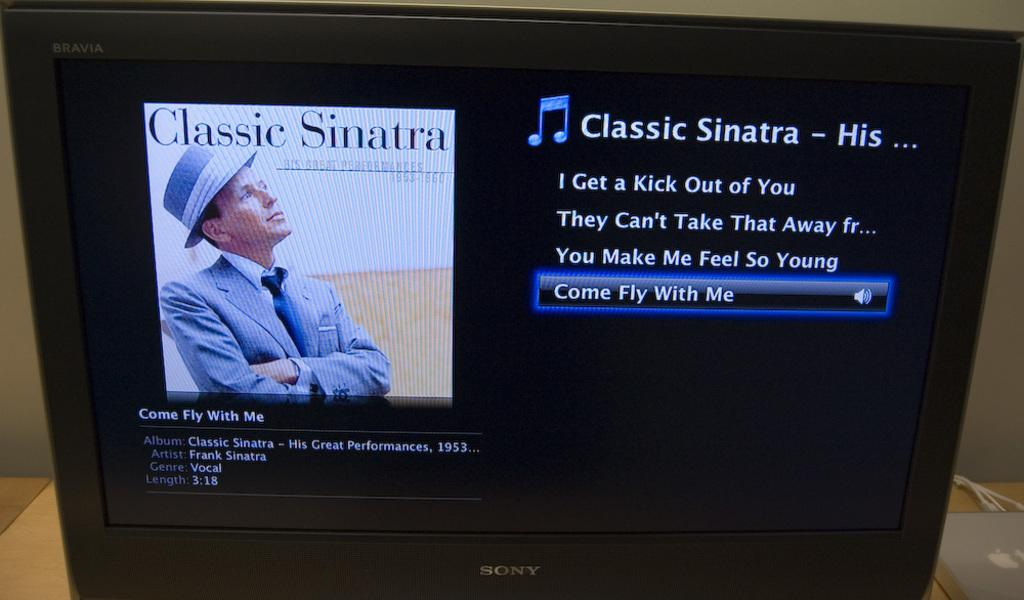<image>
Create a compact narrative representing the image presented. The screen showing a classic Sinatra album, was made by Sony. 